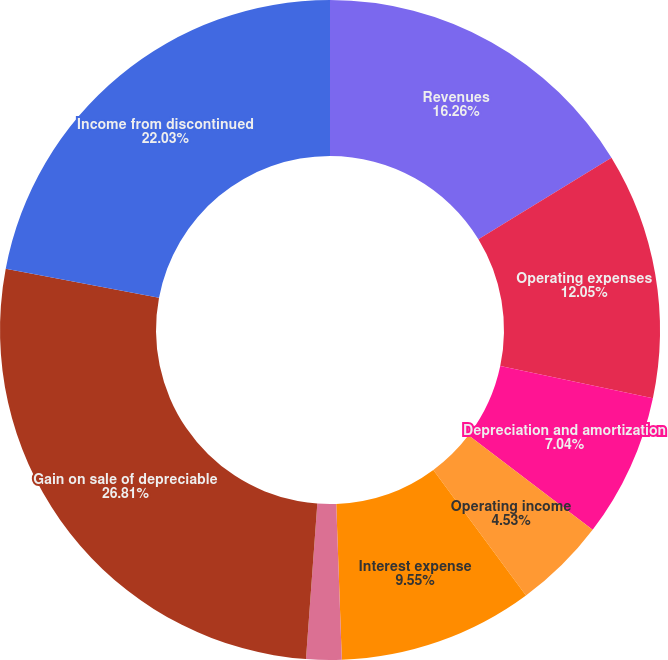Convert chart to OTSL. <chart><loc_0><loc_0><loc_500><loc_500><pie_chart><fcel>Revenues<fcel>Operating expenses<fcel>Depreciation and amortization<fcel>Operating income<fcel>Interest expense<fcel>Income (loss) before<fcel>Gain on sale of depreciable<fcel>Income from discontinued<nl><fcel>16.26%<fcel>12.05%<fcel>7.04%<fcel>4.53%<fcel>9.55%<fcel>1.73%<fcel>26.81%<fcel>22.03%<nl></chart> 